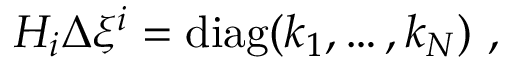<formula> <loc_0><loc_0><loc_500><loc_500>H _ { i } \Delta \xi ^ { i } = d i a g ( k _ { 1 } , \dots , k _ { N } ) ,</formula> 